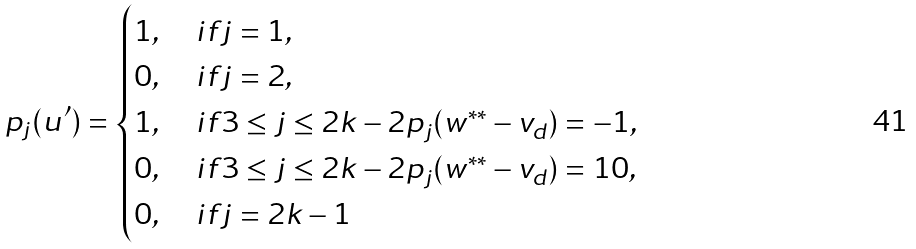<formula> <loc_0><loc_0><loc_500><loc_500>p _ { j } ( u ^ { \prime } ) = \begin{cases} 1 , \, & i f j = 1 , \\ 0 , \, & i f j = 2 , \\ 1 , \, & i f 3 \leq j \leq 2 k - 2 p _ { j } ( w ^ { * * } - v _ { d } ) = - 1 , \\ 0 , \, & i f 3 \leq j \leq 2 k - 2 p _ { j } ( w ^ { * * } - v _ { d } ) = 1 0 , \\ 0 , \, & i f j = 2 k - 1 \end{cases}</formula> 